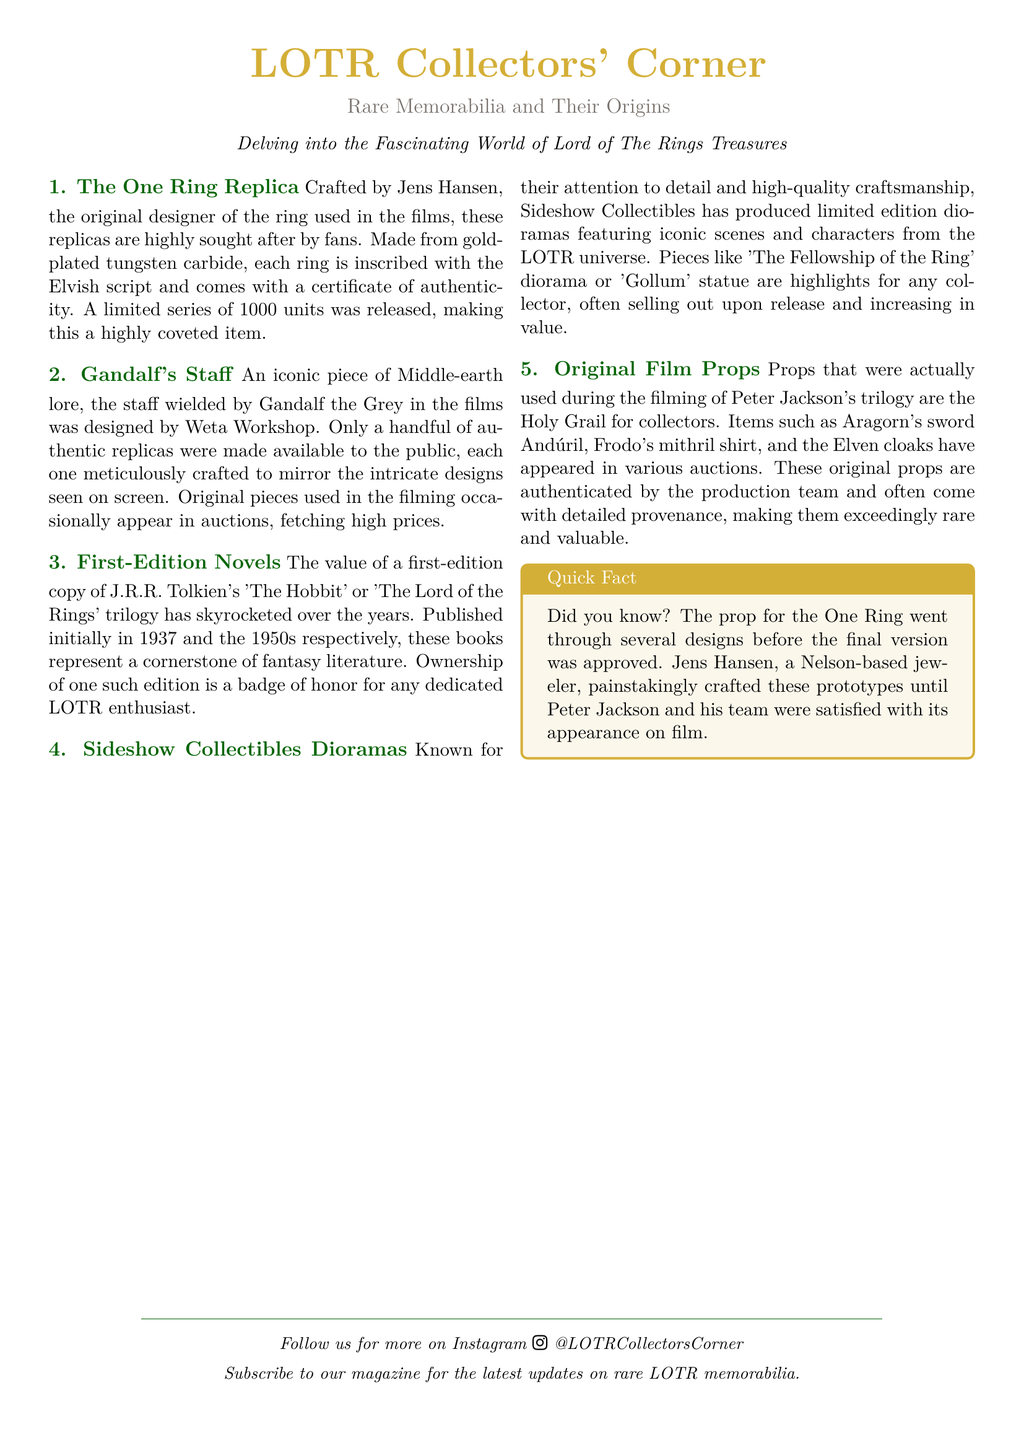What is the material of The One Ring replica? The document states that The One Ring replica is made from gold-plated tungsten carbide.
Answer: gold-plated tungsten carbide Who designed Gandalf's staff? According to the document, Gandalf's staff was designed by Weta Workshop.
Answer: Weta Workshop How many units of The One Ring replica were released? The document mentions that a limited series of 1000 units was released.
Answer: 1000 units In what year was the first edition of 'The Hobbit' published? The document indicates that 'The Hobbit' was published initially in 1937.
Answer: 1937 What is considered the Holy Grail for collectors? The document describes original film props as the Holy Grail for collectors.
Answer: original film props What type of collectibles does Sideshow Collectibles produce? According to the document, Sideshow Collectibles produces dioramas featuring iconic scenes and characters.
Answer: dioramas Which sword belonged to Aragorn in the LOTR films? The document states that Aragorn's sword is named Andúril.
Answer: Andúril What unique feature comes with The One Ring replica? The document notes that each ring comes with a certificate of authenticity.
Answer: certificate of authenticity 